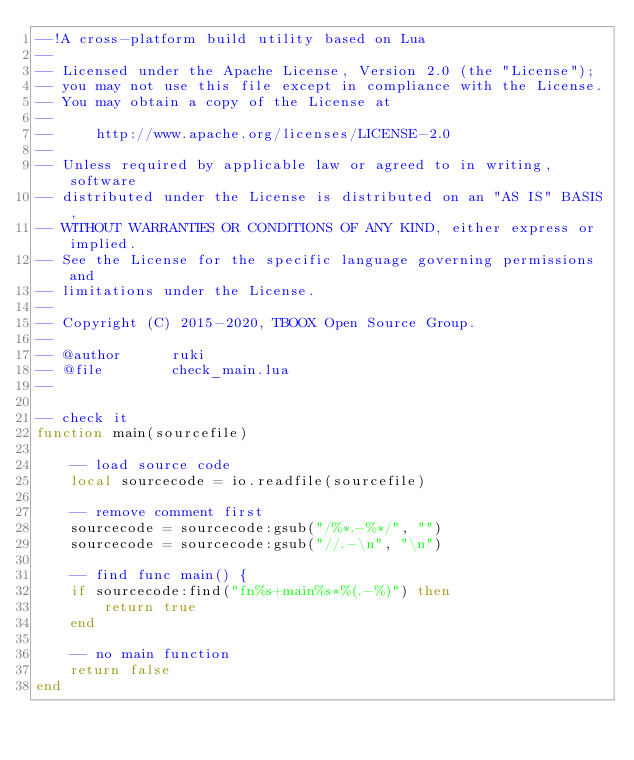Convert code to text. <code><loc_0><loc_0><loc_500><loc_500><_Lua_>--!A cross-platform build utility based on Lua
--
-- Licensed under the Apache License, Version 2.0 (the "License");
-- you may not use this file except in compliance with the License.
-- You may obtain a copy of the License at
--
--     http://www.apache.org/licenses/LICENSE-2.0
--
-- Unless required by applicable law or agreed to in writing, software
-- distributed under the License is distributed on an "AS IS" BASIS,
-- WITHOUT WARRANTIES OR CONDITIONS OF ANY KIND, either express or implied.
-- See the License for the specific language governing permissions and
-- limitations under the License.
--
-- Copyright (C) 2015-2020, TBOOX Open Source Group.
--
-- @author      ruki
-- @file        check_main.lua
--

-- check it
function main(sourcefile)

    -- load source code
    local sourcecode = io.readfile(sourcefile)

    -- remove comment first
    sourcecode = sourcecode:gsub("/%*.-%*/", "")
    sourcecode = sourcecode:gsub("//.-\n", "\n")

    -- find func main() {
    if sourcecode:find("fn%s+main%s*%(.-%)") then
        return true
    end

    -- no main function
    return false
end


</code> 